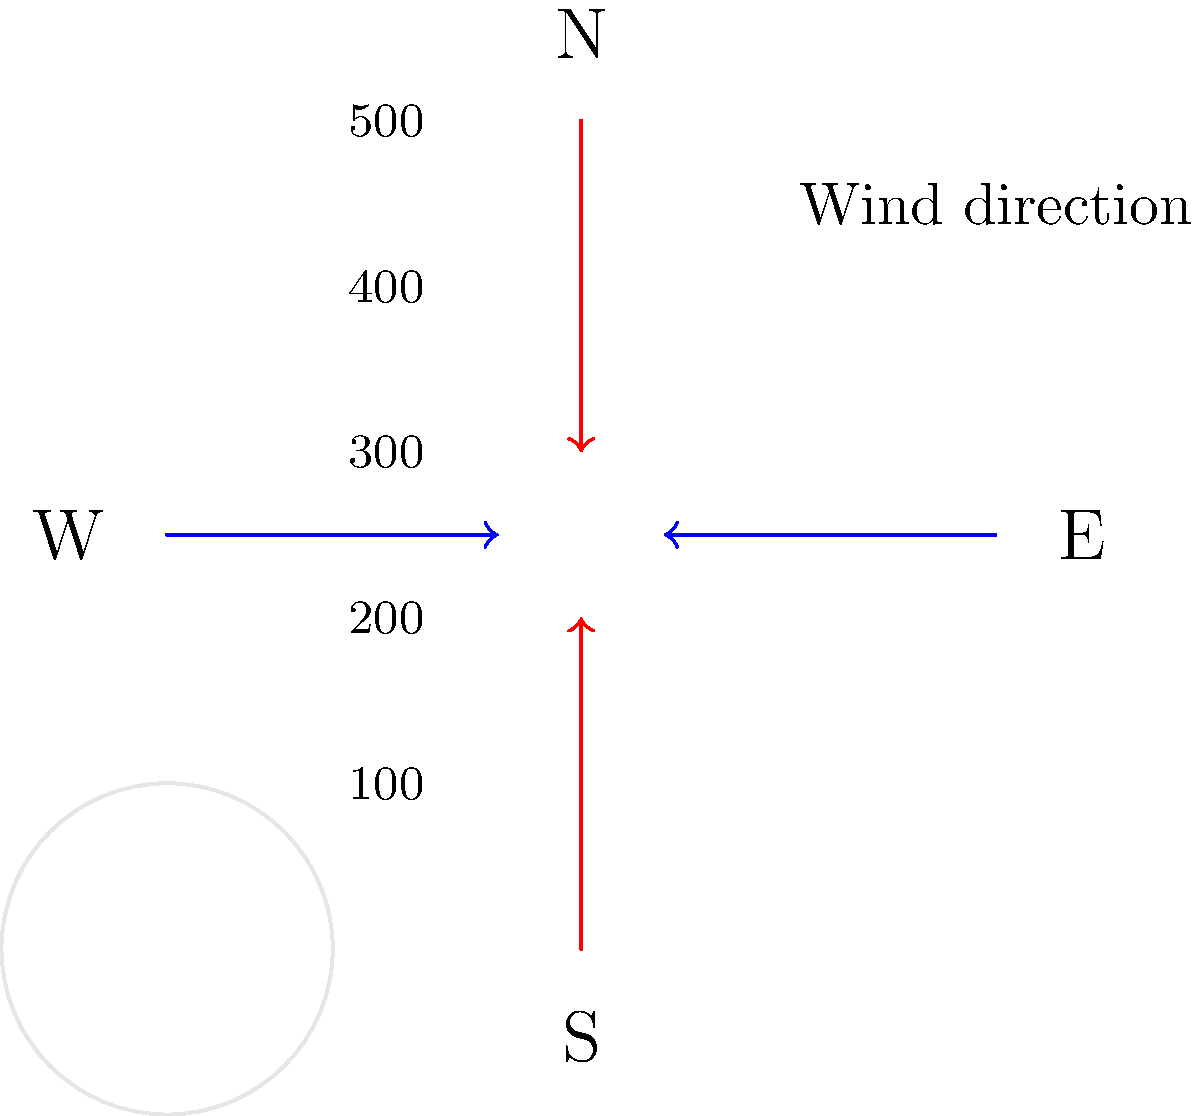As a concerned eco-conscious Australian farmer, you're analyzing wind patterns to mitigate soil erosion on your property. The topographic map shows elevation contours (in meters) and wind directions. Which slope aspect is most vulnerable to wind erosion, and what sustainable farming practice would you implement to protect it? To determine the most vulnerable slope and appropriate sustainable farming practice, let's analyze the map step-by-step:

1. Interpret the map:
   - Contour lines represent elevation, with higher elevations towards the center.
   - Blue arrows show the prevailing wind direction (east to west).
   - Red arrows show a secondary wind direction (north to south).

2. Identify vulnerable slopes:
   - Western slopes face the prevailing wind directly.
   - Southern slopes face the secondary wind.

3. Assess erosion risk:
   - Western slopes are most vulnerable due to:
     a) Direct exposure to prevailing winds.
     b) Steeper gradient (contour lines are closer together).

4. Consider sustainable farming practices:
   - Contour plowing: Plowing along contour lines to reduce runoff.
   - Windbreaks: Planting trees or shrubs perpendicular to wind direction.
   - Cover crops: Planting vegetation to protect soil when main crop is not present.
   - Conservation tillage: Minimizing soil disturbance to maintain organic matter.

5. Select the most effective practice:
   - Windbreaks are most suitable because they:
     a) Directly address the wind erosion problem.
     b) Provide long-term protection.
     c) Offer additional benefits like habitat for beneficial insects and birds.

Therefore, the western slopes are most vulnerable, and implementing windbreaks would be the most effective sustainable farming practice to protect them.
Answer: Western slopes; implement windbreaks 